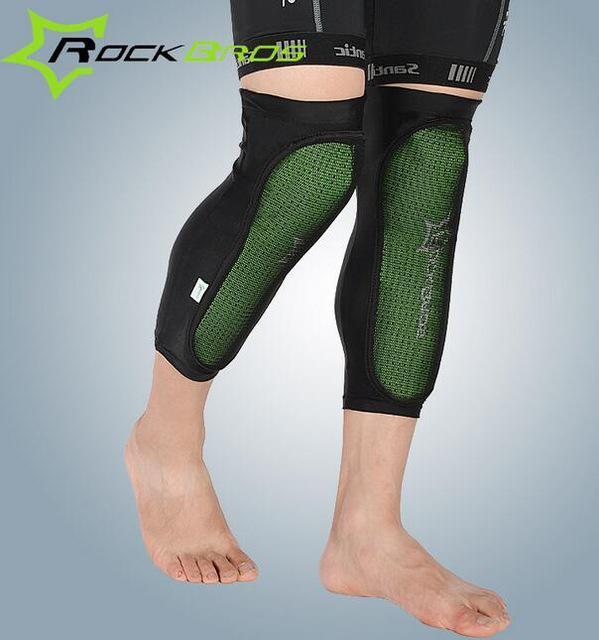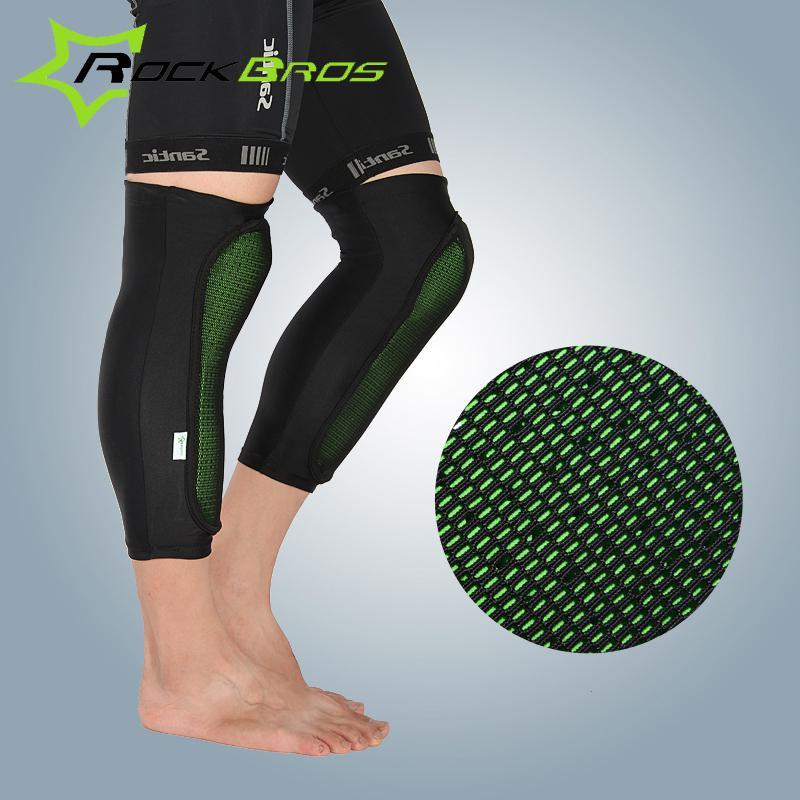The first image is the image on the left, the second image is the image on the right. For the images displayed, is the sentence "There are two pairs of legs and two pairs of leg braces." factually correct? Answer yes or no. Yes. 